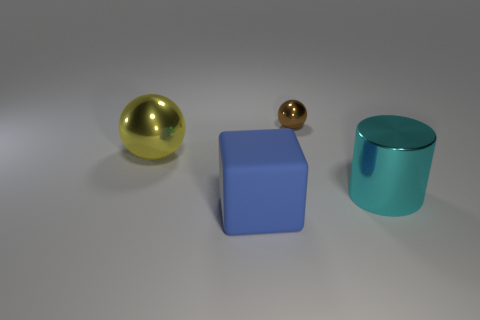Are there any other things that have the same material as the large block?
Give a very brief answer. No. Is there a big blue block that has the same material as the big cyan cylinder?
Your answer should be very brief. No. Is the material of the large cyan object that is right of the large blue cube the same as the blue cube?
Make the answer very short. No. Are there more brown balls that are to the right of the cyan shiny cylinder than big blue things that are behind the large yellow metal sphere?
Your response must be concise. No. What color is the block that is the same size as the cyan shiny cylinder?
Keep it short and to the point. Blue. Is there another big metal cylinder that has the same color as the large cylinder?
Provide a succinct answer. No. Does the big metallic thing right of the big yellow ball have the same color as the thing that is to the left of the matte cube?
Your response must be concise. No. There is a sphere that is behind the large yellow ball; what is it made of?
Provide a succinct answer. Metal. What is the color of the cylinder that is made of the same material as the brown thing?
Offer a very short reply. Cyan. What number of yellow objects have the same size as the blue object?
Offer a very short reply. 1. 